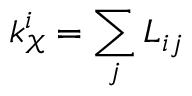<formula> <loc_0><loc_0><loc_500><loc_500>k _ { \mathcal { X } } ^ { i } = \sum _ { j } L _ { i j }</formula> 